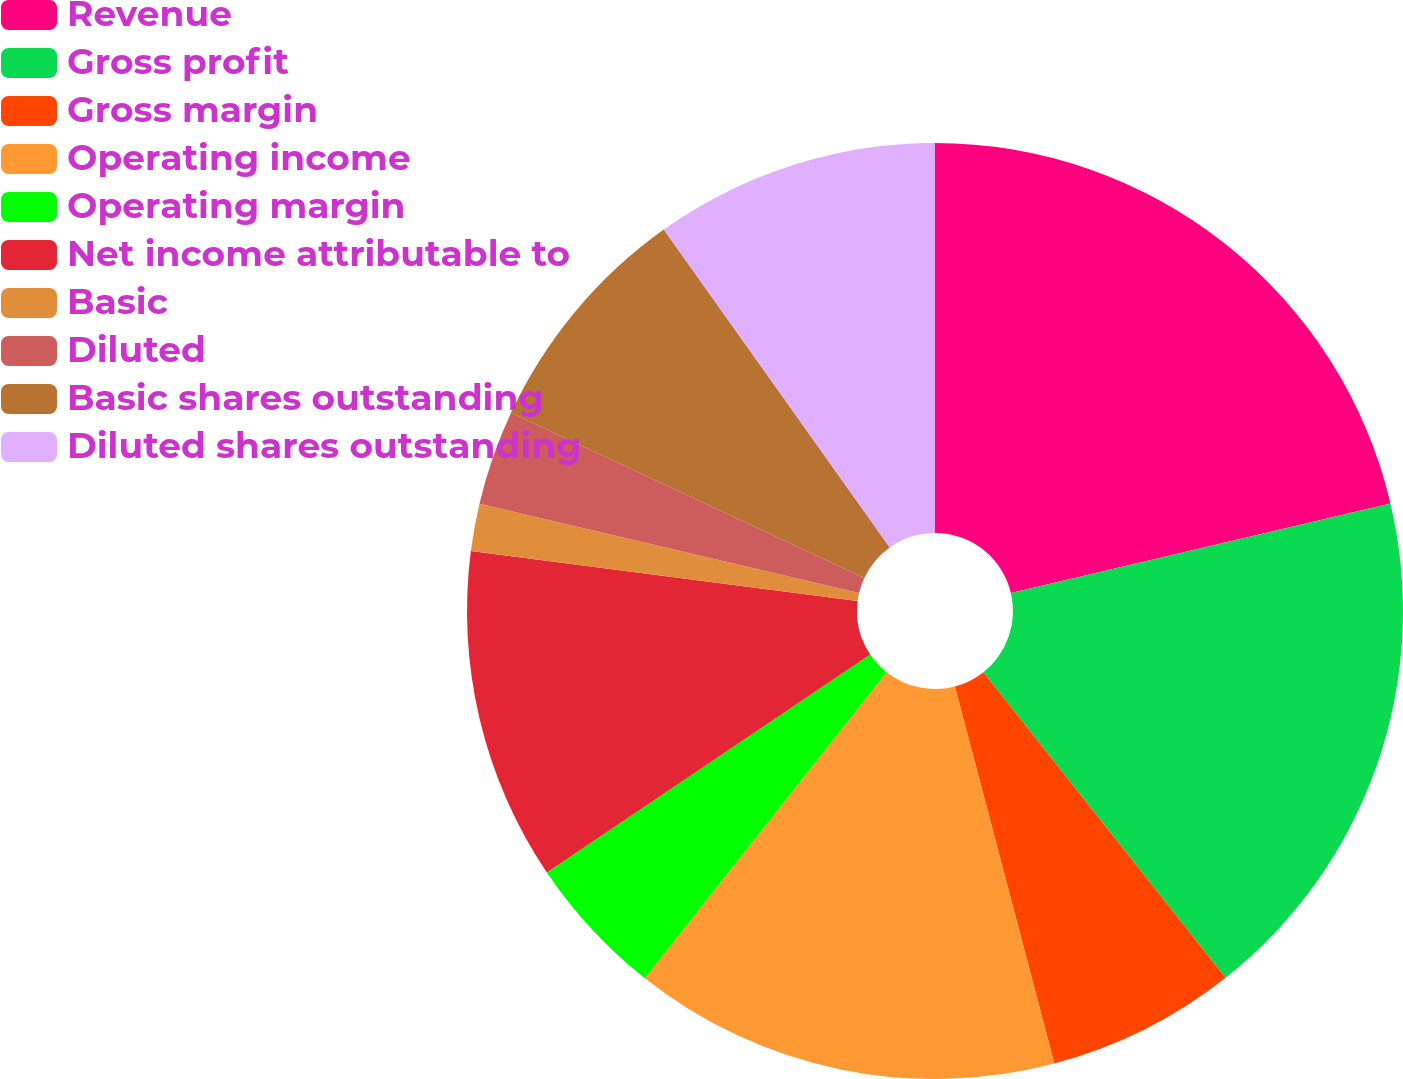Convert chart. <chart><loc_0><loc_0><loc_500><loc_500><pie_chart><fcel>Revenue<fcel>Gross profit<fcel>Gross margin<fcel>Operating income<fcel>Operating margin<fcel>Net income attributable to<fcel>Basic<fcel>Diluted<fcel>Basic shares outstanding<fcel>Diluted shares outstanding<nl><fcel>21.31%<fcel>18.03%<fcel>6.56%<fcel>14.75%<fcel>4.92%<fcel>11.48%<fcel>1.64%<fcel>3.28%<fcel>8.2%<fcel>9.84%<nl></chart> 